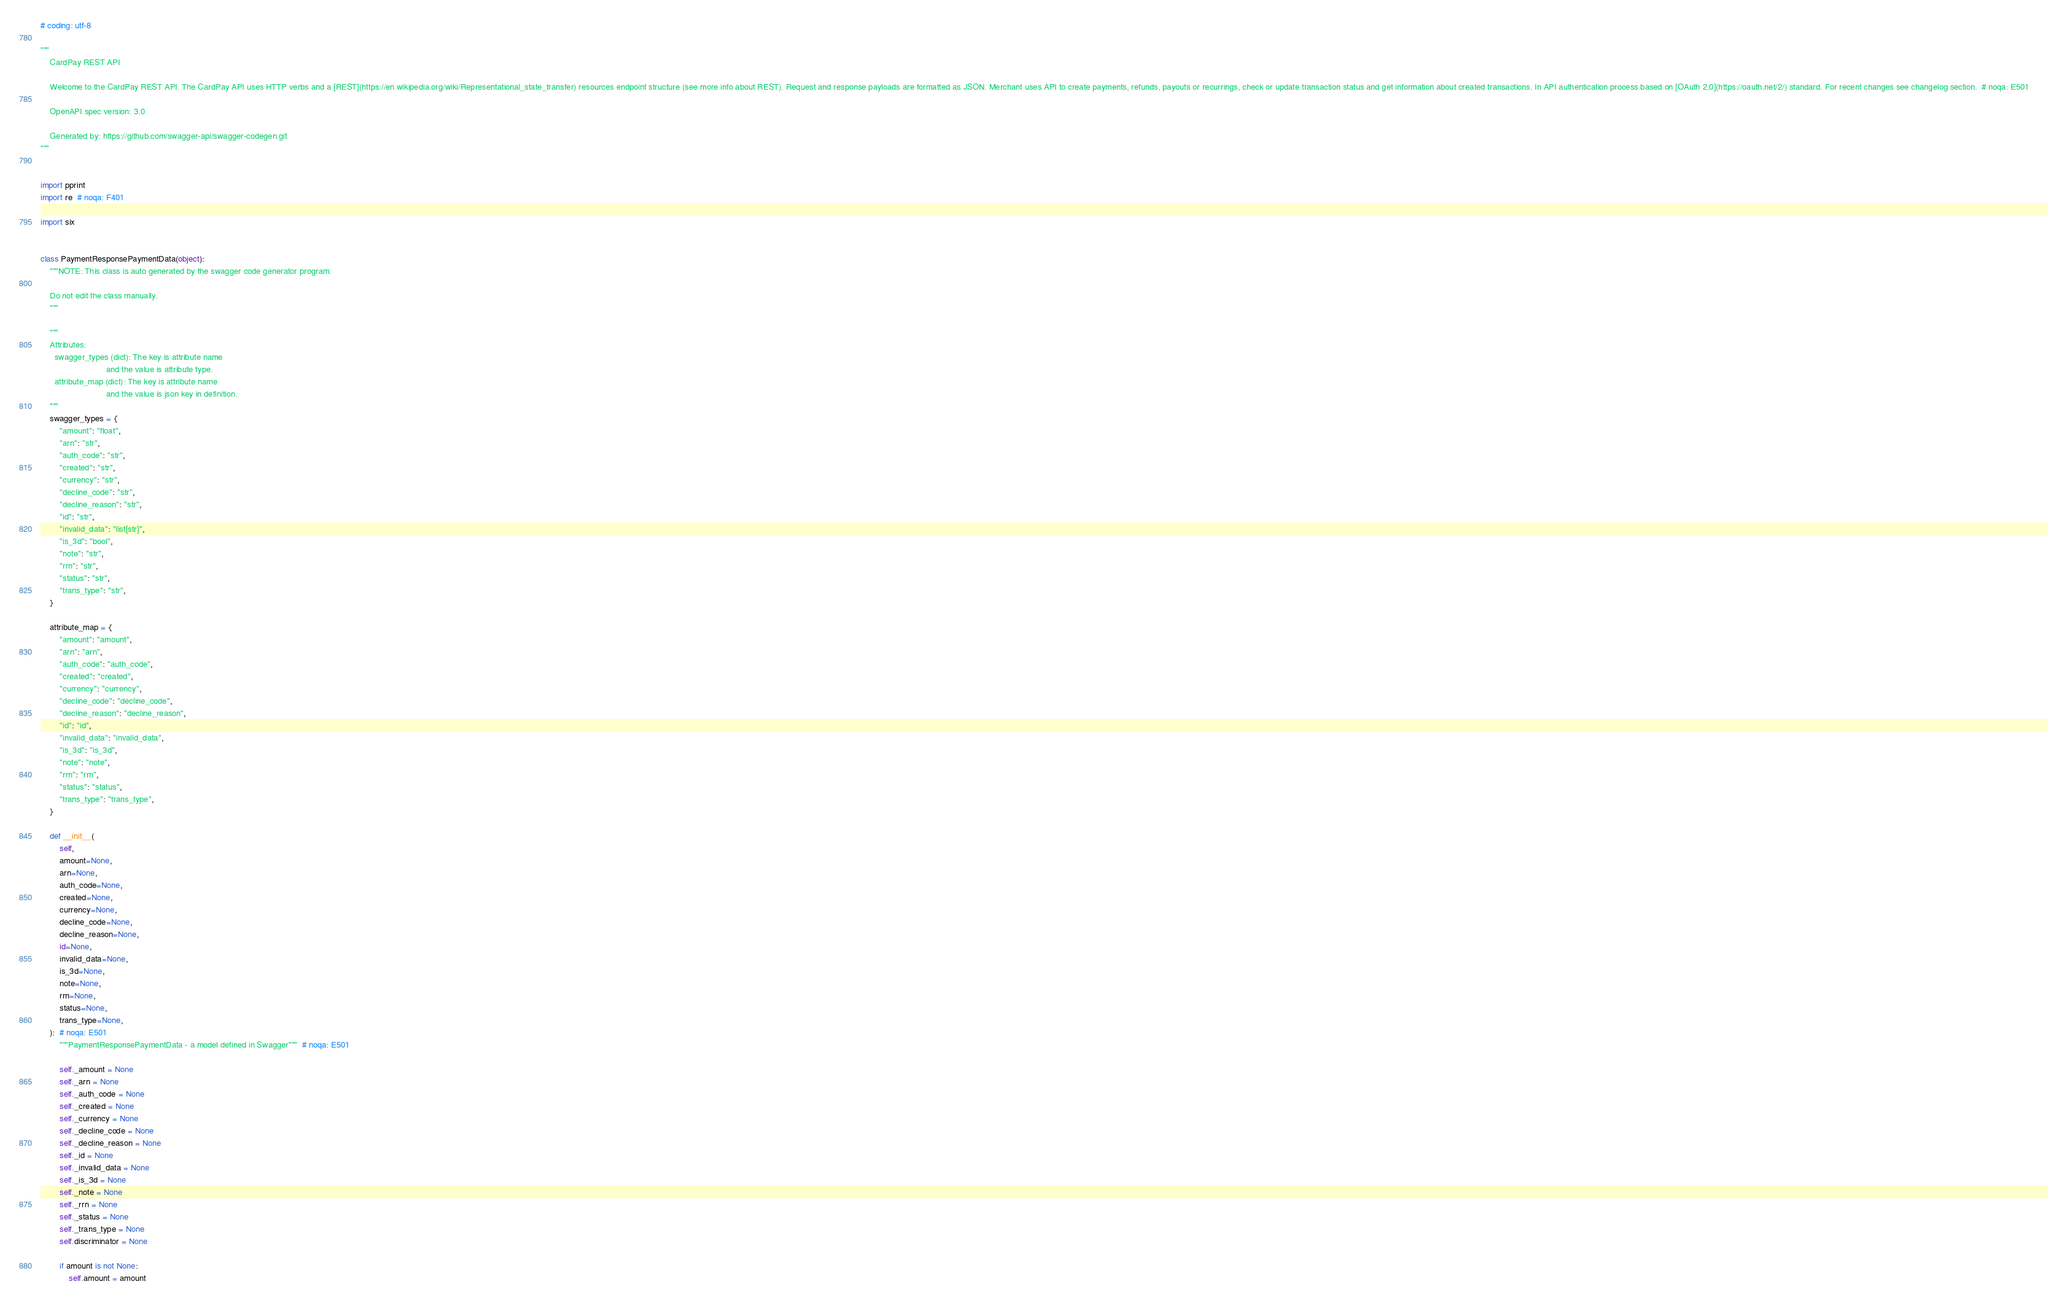<code> <loc_0><loc_0><loc_500><loc_500><_Python_># coding: utf-8

"""
    CardPay REST API

    Welcome to the CardPay REST API. The CardPay API uses HTTP verbs and a [REST](https://en.wikipedia.org/wiki/Representational_state_transfer) resources endpoint structure (see more info about REST). Request and response payloads are formatted as JSON. Merchant uses API to create payments, refunds, payouts or recurrings, check or update transaction status and get information about created transactions. In API authentication process based on [OAuth 2.0](https://oauth.net/2/) standard. For recent changes see changelog section.  # noqa: E501

    OpenAPI spec version: 3.0
    
    Generated by: https://github.com/swagger-api/swagger-codegen.git
"""


import pprint
import re  # noqa: F401

import six


class PaymentResponsePaymentData(object):
    """NOTE: This class is auto generated by the swagger code generator program.

    Do not edit the class manually.
    """

    """
    Attributes:
      swagger_types (dict): The key is attribute name
                            and the value is attribute type.
      attribute_map (dict): The key is attribute name
                            and the value is json key in definition.
    """
    swagger_types = {
        "amount": "float",
        "arn": "str",
        "auth_code": "str",
        "created": "str",
        "currency": "str",
        "decline_code": "str",
        "decline_reason": "str",
        "id": "str",
        "invalid_data": "list[str]",
        "is_3d": "bool",
        "note": "str",
        "rrn": "str",
        "status": "str",
        "trans_type": "str",
    }

    attribute_map = {
        "amount": "amount",
        "arn": "arn",
        "auth_code": "auth_code",
        "created": "created",
        "currency": "currency",
        "decline_code": "decline_code",
        "decline_reason": "decline_reason",
        "id": "id",
        "invalid_data": "invalid_data",
        "is_3d": "is_3d",
        "note": "note",
        "rrn": "rrn",
        "status": "status",
        "trans_type": "trans_type",
    }

    def __init__(
        self,
        amount=None,
        arn=None,
        auth_code=None,
        created=None,
        currency=None,
        decline_code=None,
        decline_reason=None,
        id=None,
        invalid_data=None,
        is_3d=None,
        note=None,
        rrn=None,
        status=None,
        trans_type=None,
    ):  # noqa: E501
        """PaymentResponsePaymentData - a model defined in Swagger"""  # noqa: E501

        self._amount = None
        self._arn = None
        self._auth_code = None
        self._created = None
        self._currency = None
        self._decline_code = None
        self._decline_reason = None
        self._id = None
        self._invalid_data = None
        self._is_3d = None
        self._note = None
        self._rrn = None
        self._status = None
        self._trans_type = None
        self.discriminator = None

        if amount is not None:
            self.amount = amount</code> 